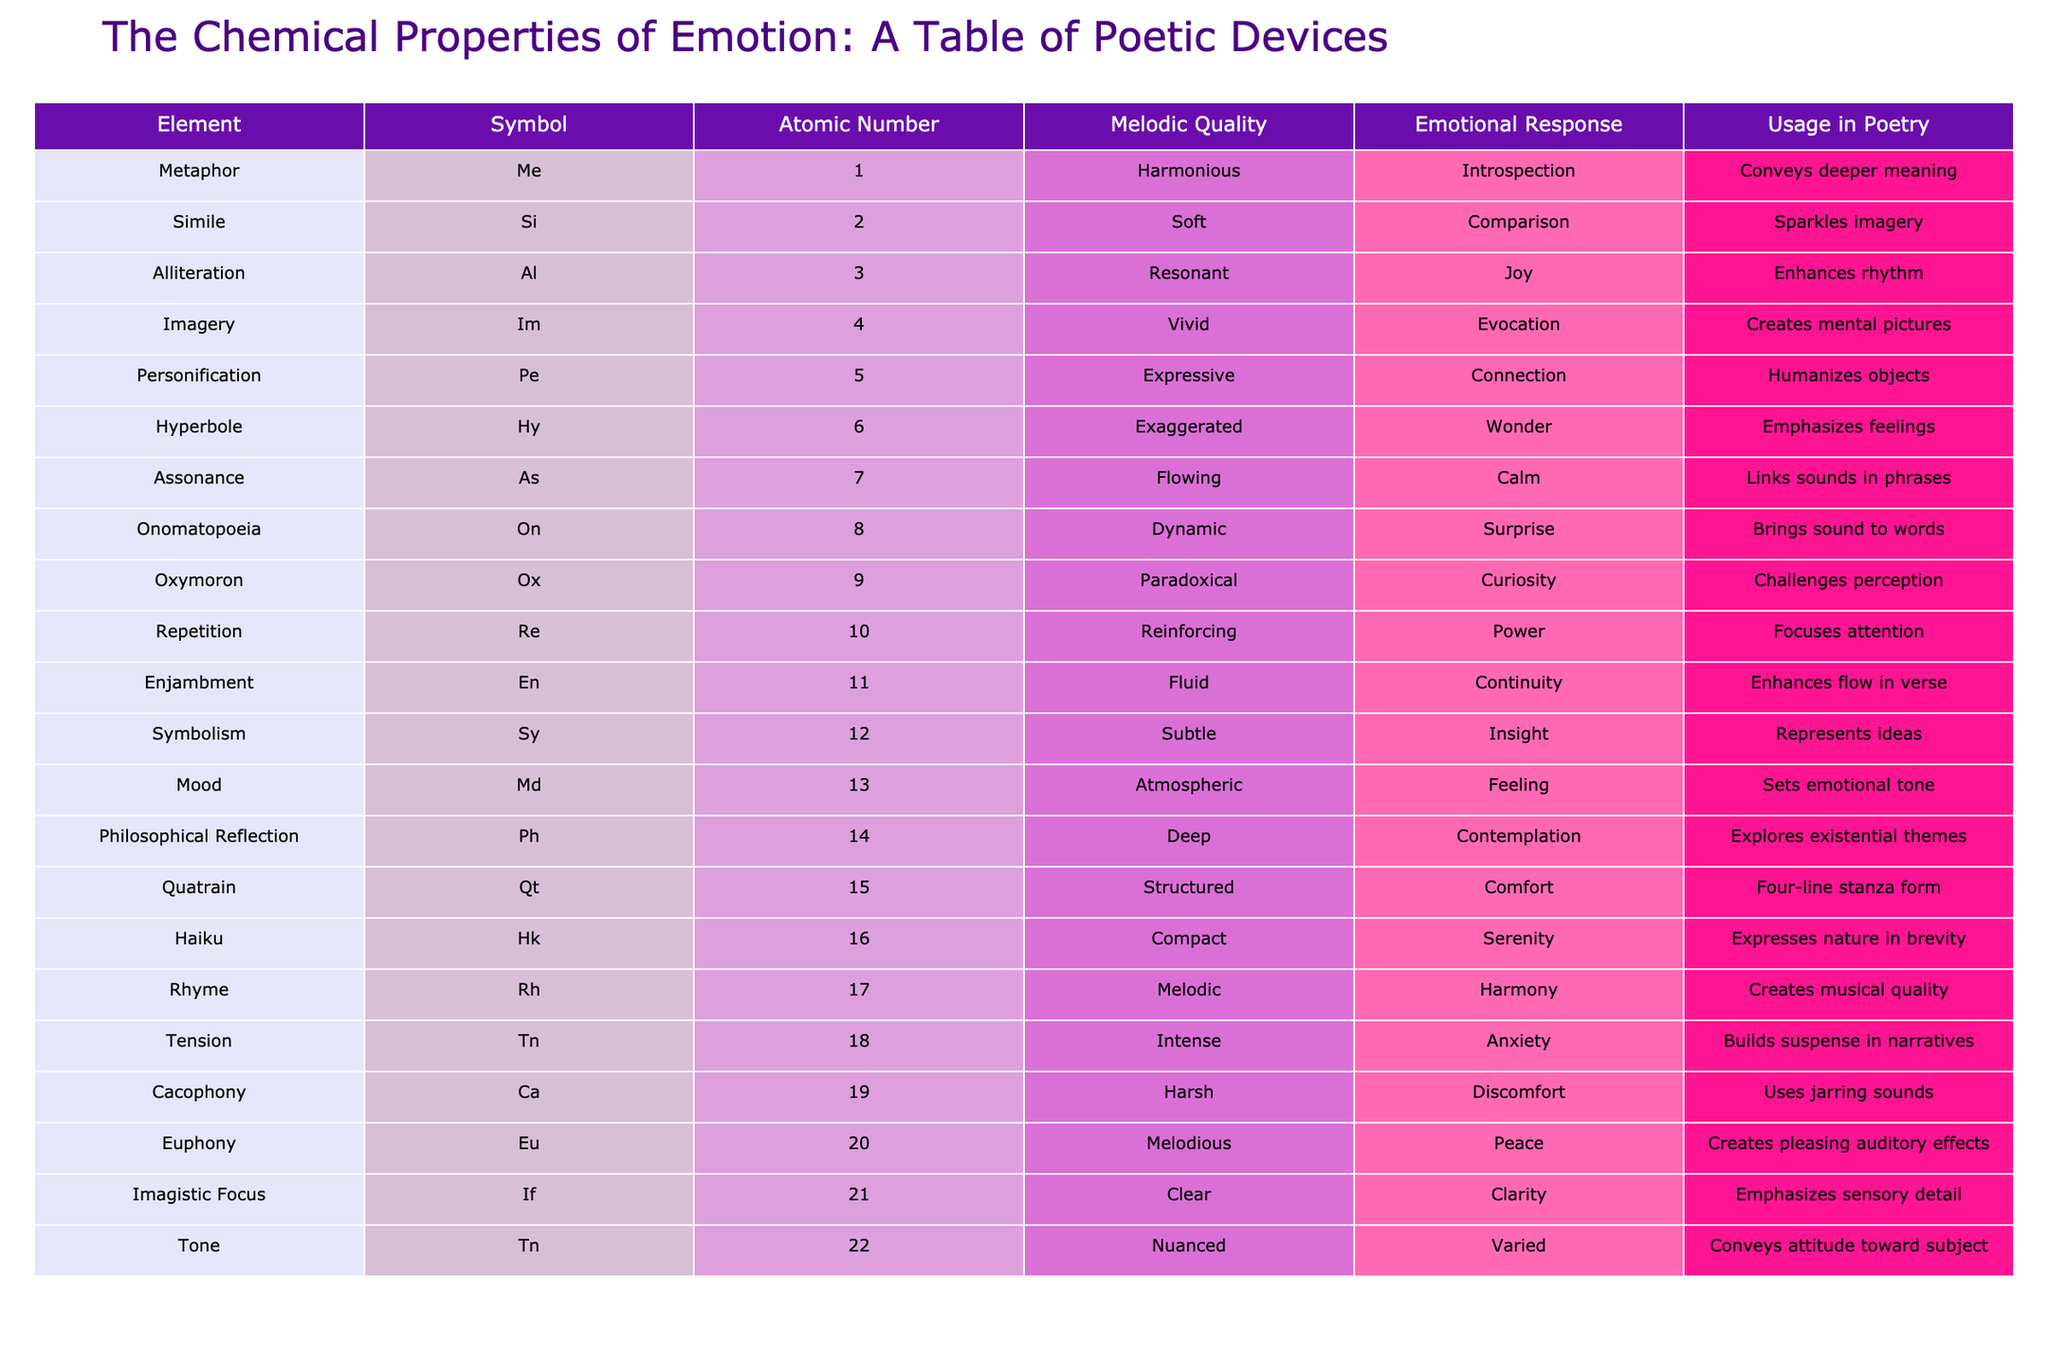What is the symbol for Imagery? The symbol for Imagery is "Im" as listed in the table under the Symbol column.
Answer: Im Which poetic device has the atomic number 3? The poetic device with the atomic number 3 is Alliteration, as indicated in the table where Alliteration is listed with the number 3.
Answer: Alliteration Does Hyperbole evoke wonder? Yes, Hyperbole does evoke wonder as per the Emotional Response column in the table which states that Hyperbole's emotional response is "Wonder."
Answer: Yes What are the Melodic Qualities of Personification and Oxymoron? The Melodic Quality of Personification is "Expressive" and that of Oxymoron is "Paradoxical," as noted in the respective rows for these devices in the Melodic Quality column.
Answer: Expressive; Paradoxical What is the average atomic number of the devices that convey deeper meaning? The device that conveys deeper meaning is Metaphor, which has the atomic number 1. Since it's the only device that fits this category, the average atomic number is simply 1.
Answer: 1 How many poetic devices have a Melodic Quality described as "Dynamic" or "Flowing"? Only one poetic device, Onomatopoeia, has a Melodic Quality described as "Dynamic," and one device, Assonance, is described as "Flowing." Thus, there are 2 devices in total with these qualities.
Answer: 2 Is the emotional response of Cacophony discomfort? Yes, the emotional response of Cacophony is indeed discomfort, as clearly indicated in the Emotional Response column.
Answer: Yes Which poetic device enhances flow in verse? The poetic device that enhances flow in verse is Enjambment, as stated in the Usage in Poetry column for this row.
Answer: Enjambment What is the difference in emotional response between Cacophony and Euphony? Cacophony elicits discomfort while Euphony creates a feeling of peace. The difference in their emotional responses can be seen contrasting the respective entries in the Emotional Response column.
Answer: Discomfort; Peace 